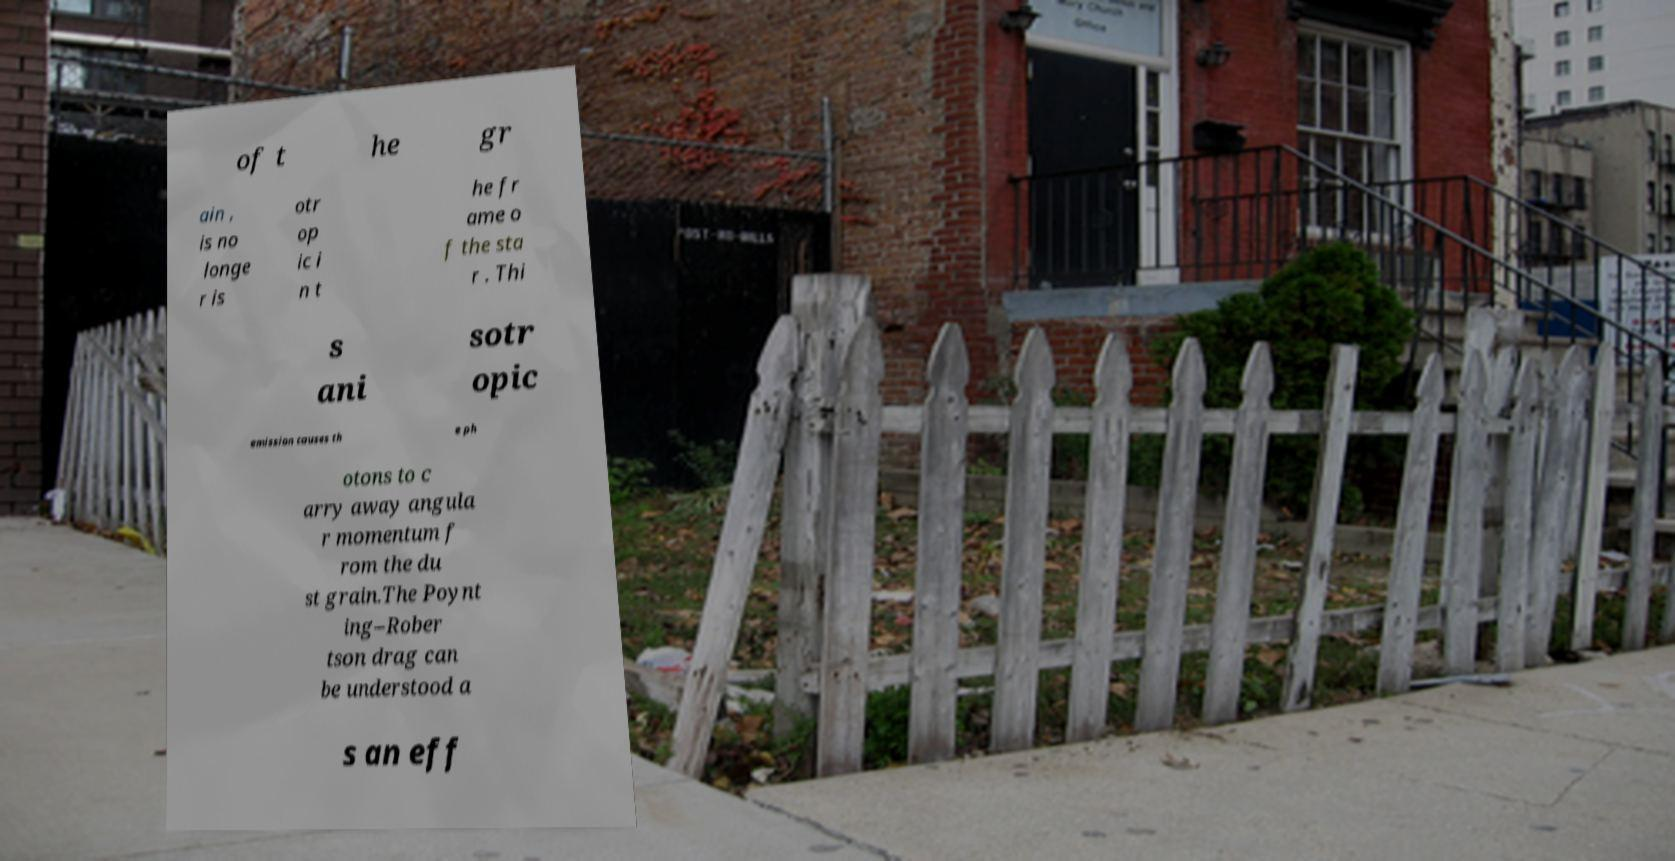Please identify and transcribe the text found in this image. of t he gr ain , is no longe r is otr op ic i n t he fr ame o f the sta r . Thi s ani sotr opic emission causes th e ph otons to c arry away angula r momentum f rom the du st grain.The Poynt ing–Rober tson drag can be understood a s an eff 